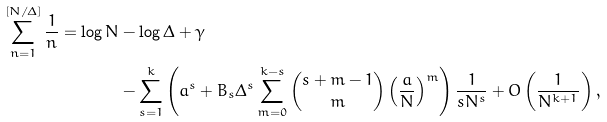<formula> <loc_0><loc_0><loc_500><loc_500>\sum _ { n = 1 } ^ { [ N / \Delta ] } \frac { 1 } { n } = \log N & - \log \Delta + \gamma \\ & - \sum _ { s = 1 } ^ { k } \left ( a ^ { s } + B _ { s } \Delta ^ { s } \sum _ { m = 0 } ^ { k - s } \binom { s + m - 1 } { m } \left ( \frac { a } { N } \right ) ^ { m } \right ) \frac { 1 } { s N ^ { s } } + O \left ( \frac { 1 } { N ^ { k + 1 } } \right ) ,</formula> 